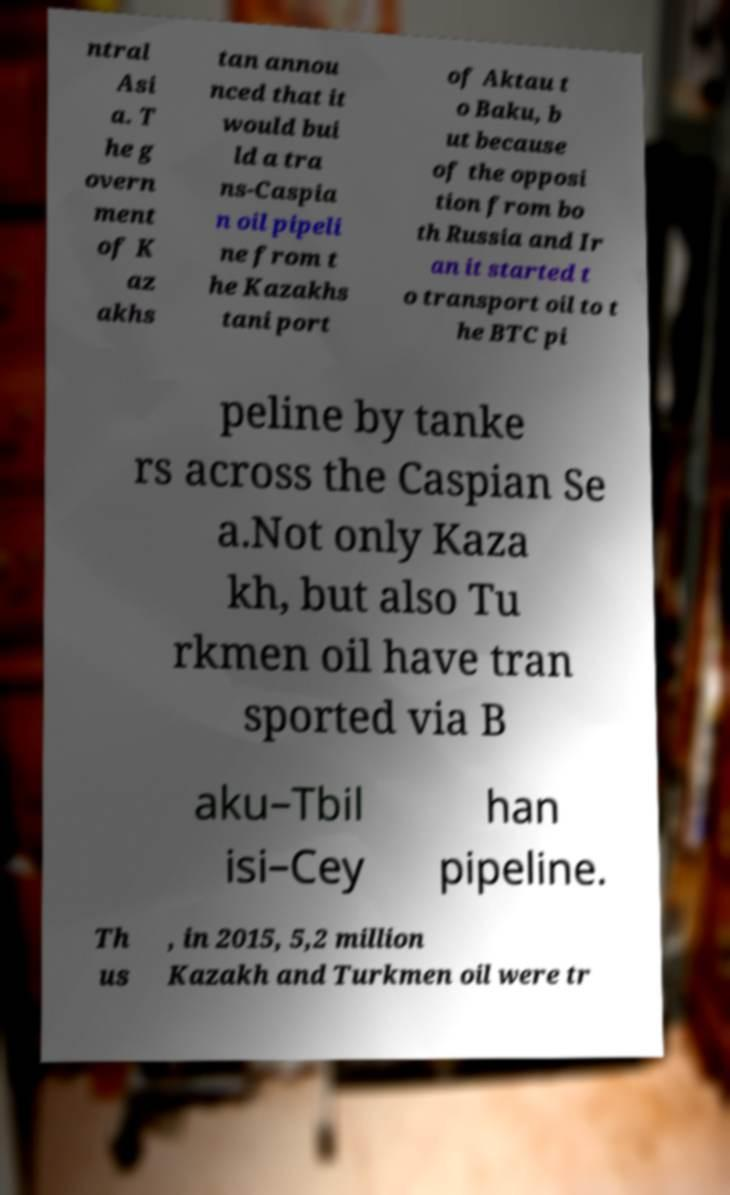Could you extract and type out the text from this image? ntral Asi a. T he g overn ment of K az akhs tan annou nced that it would bui ld a tra ns-Caspia n oil pipeli ne from t he Kazakhs tani port of Aktau t o Baku, b ut because of the opposi tion from bo th Russia and Ir an it started t o transport oil to t he BTC pi peline by tanke rs across the Caspian Se a.Not only Kaza kh, but also Tu rkmen oil have tran sported via B aku–Tbil isi–Cey han pipeline. Th us , in 2015, 5,2 million Kazakh and Turkmen oil were tr 